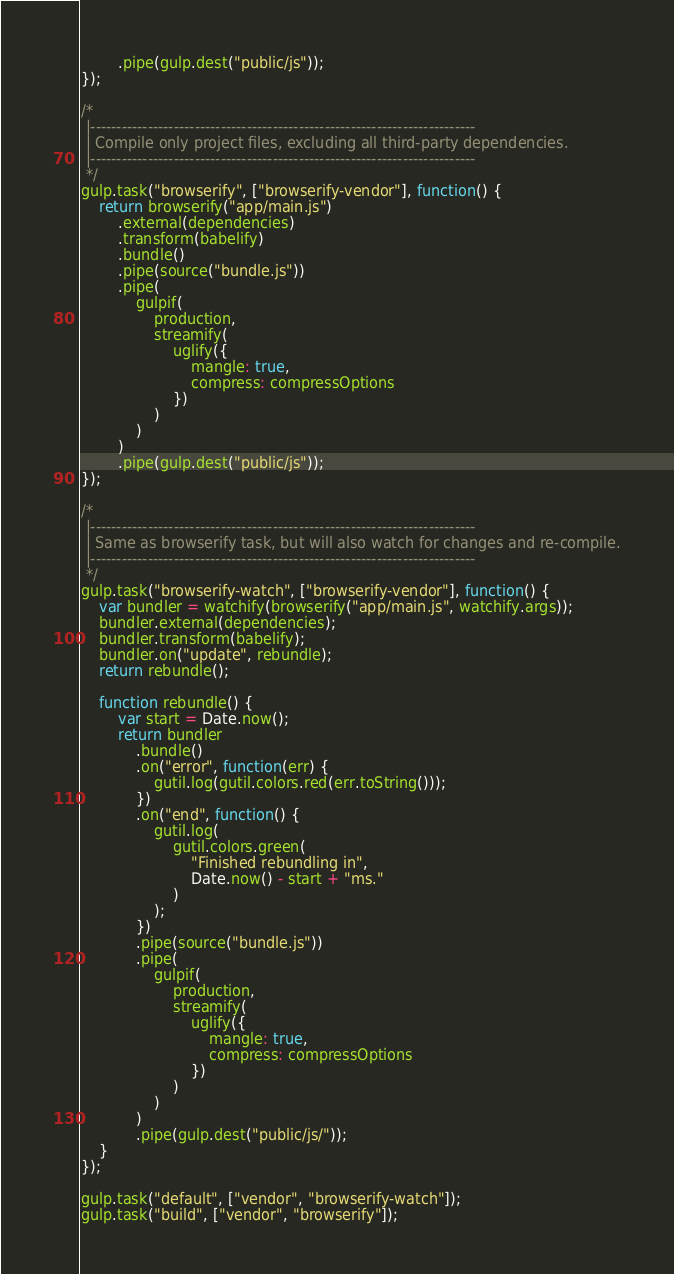<code> <loc_0><loc_0><loc_500><loc_500><_JavaScript_>        .pipe(gulp.dest("public/js"));
});

/*
 |--------------------------------------------------------------------------
 | Compile only project files, excluding all third-party dependencies.
 |--------------------------------------------------------------------------
 */
gulp.task("browserify", ["browserify-vendor"], function() {
    return browserify("app/main.js")
        .external(dependencies)
        .transform(babelify)
        .bundle()
        .pipe(source("bundle.js"))
        .pipe(
            gulpif(
                production,
                streamify(
                    uglify({
                        mangle: true,
                        compress: compressOptions
                    })
                )
            )
        )
        .pipe(gulp.dest("public/js"));
});

/*
 |--------------------------------------------------------------------------
 | Same as browserify task, but will also watch for changes and re-compile.
 |--------------------------------------------------------------------------
 */
gulp.task("browserify-watch", ["browserify-vendor"], function() {
    var bundler = watchify(browserify("app/main.js", watchify.args));
    bundler.external(dependencies);
    bundler.transform(babelify);
    bundler.on("update", rebundle);
    return rebundle();

    function rebundle() {
        var start = Date.now();
        return bundler
            .bundle()
            .on("error", function(err) {
                gutil.log(gutil.colors.red(err.toString()));
            })
            .on("end", function() {
                gutil.log(
                    gutil.colors.green(
                        "Finished rebundling in",
                        Date.now() - start + "ms."
                    )
                );
            })
            .pipe(source("bundle.js"))
            .pipe(
                gulpif(
                    production,
                    streamify(
                        uglify({
                            mangle: true,
                            compress: compressOptions
                        })
                    )
                )
            )
            .pipe(gulp.dest("public/js/"));
    }
});

gulp.task("default", ["vendor", "browserify-watch"]);
gulp.task("build", ["vendor", "browserify"]);
</code> 